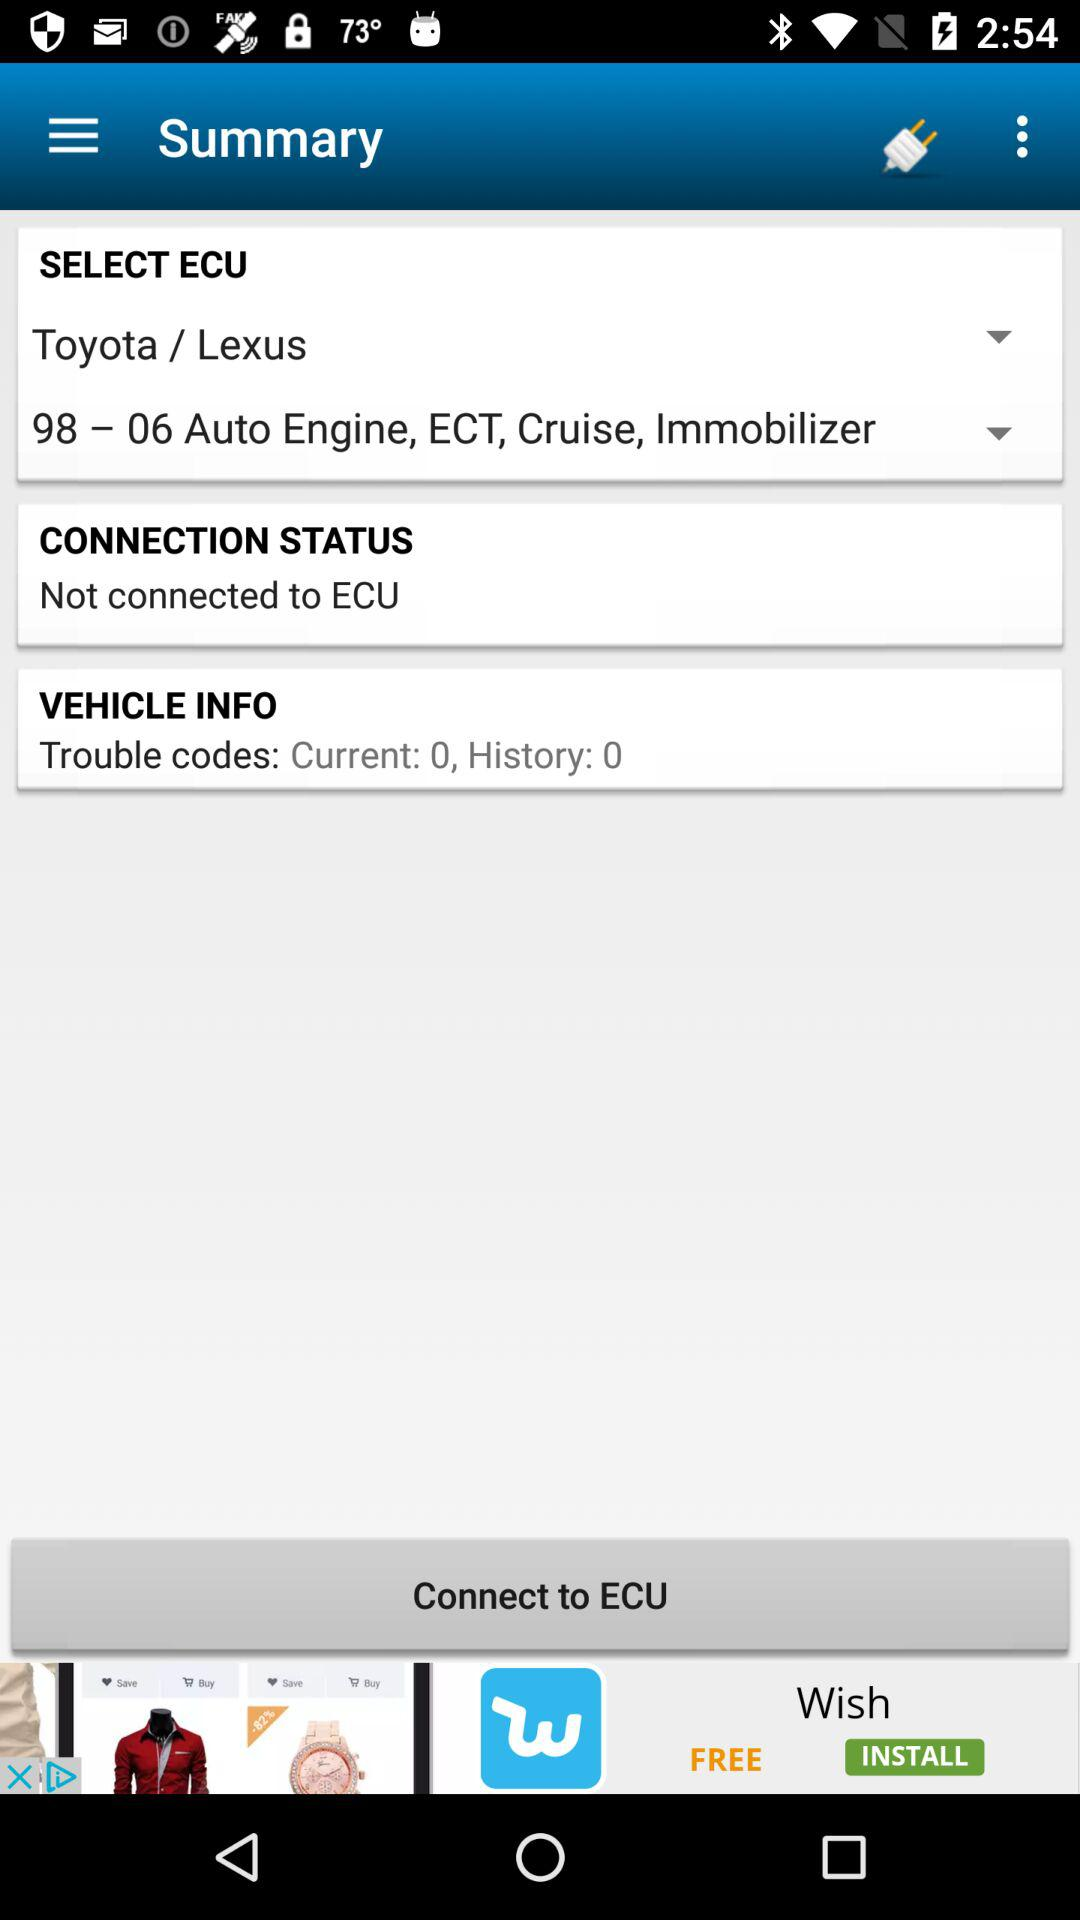How many trouble codes are there?
Answer the question using a single word or phrase. 0 